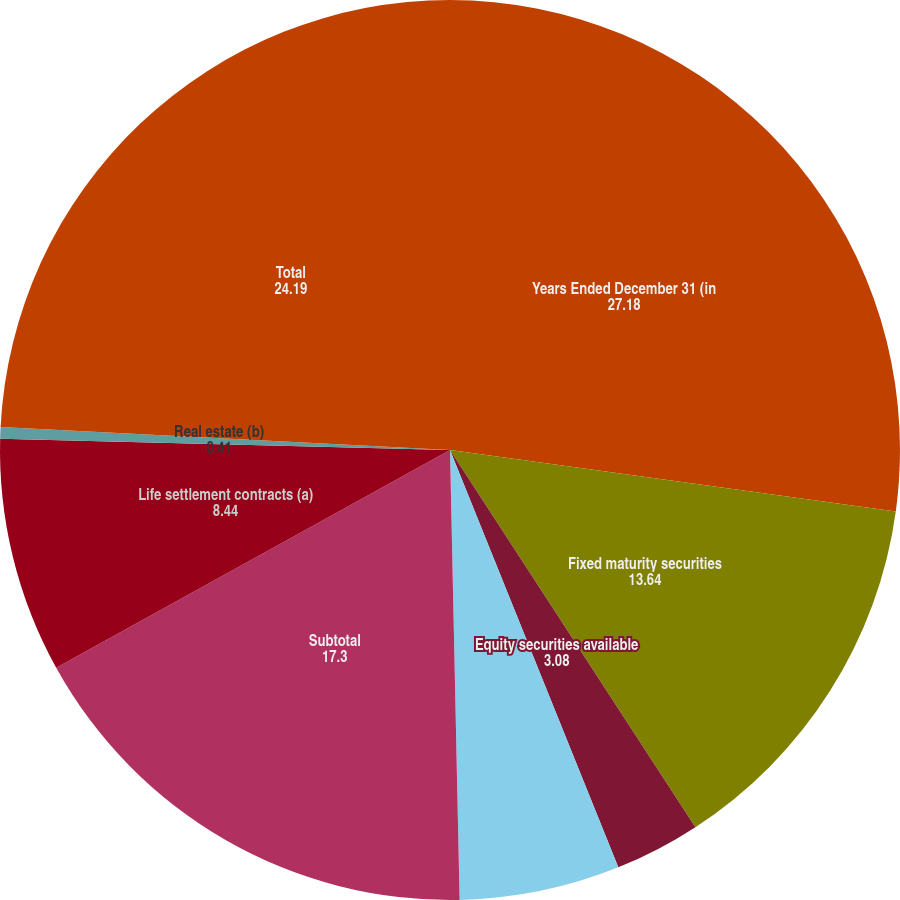<chart> <loc_0><loc_0><loc_500><loc_500><pie_chart><fcel>Years Ended December 31 (in<fcel>Fixed maturity securities<fcel>Equity securities available<fcel>Private equity funds and hedge<fcel>Subtotal<fcel>Life settlement contracts (a)<fcel>Real estate (b)<fcel>Total<nl><fcel>27.18%<fcel>13.64%<fcel>3.08%<fcel>5.76%<fcel>17.3%<fcel>8.44%<fcel>0.41%<fcel>24.19%<nl></chart> 